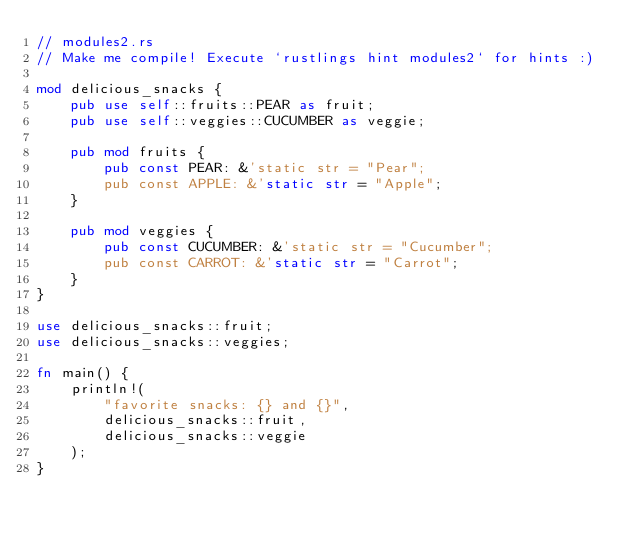Convert code to text. <code><loc_0><loc_0><loc_500><loc_500><_Rust_>// modules2.rs
// Make me compile! Execute `rustlings hint modules2` for hints :)

mod delicious_snacks {
    pub use self::fruits::PEAR as fruit;
    pub use self::veggies::CUCUMBER as veggie;

    pub mod fruits {
        pub const PEAR: &'static str = "Pear";
        pub const APPLE: &'static str = "Apple";
    }

    pub mod veggies {
        pub const CUCUMBER: &'static str = "Cucumber";
        pub const CARROT: &'static str = "Carrot";
    }
}

use delicious_snacks::fruit;
use delicious_snacks::veggies;

fn main() {
    println!(
        "favorite snacks: {} and {}",
        delicious_snacks::fruit,
        delicious_snacks::veggie
    );
}
</code> 